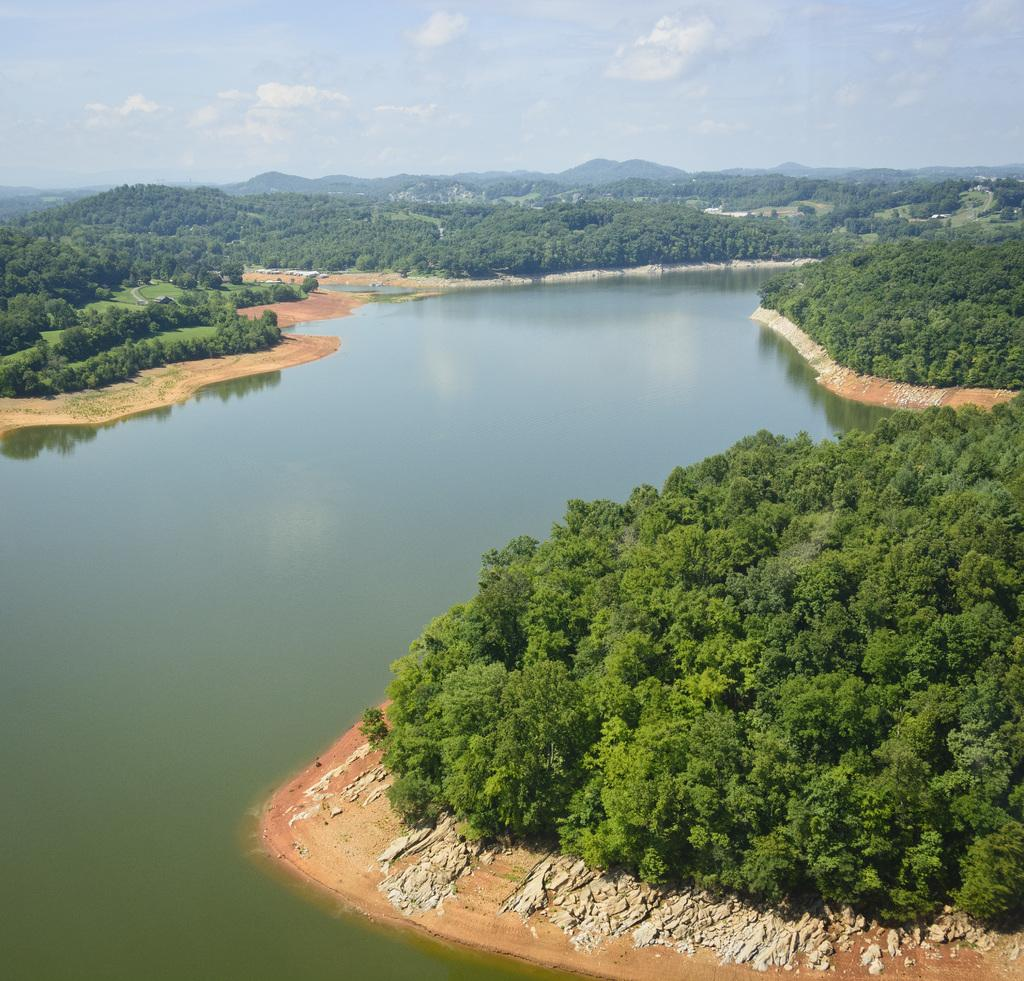What is one of the main elements in the image? There is water in the image. What type of vegetation can be seen in the image? There are trees in the image. What other objects are present in the image? There are stones in the image. What can be seen in the distance at the top of the image? There are hills visible at the top of the image. How would you describe the sky in the image? The sky is cloudy in the image. What shape is the head of the person in the image? There is no person present in the image, so there is no head to describe. 